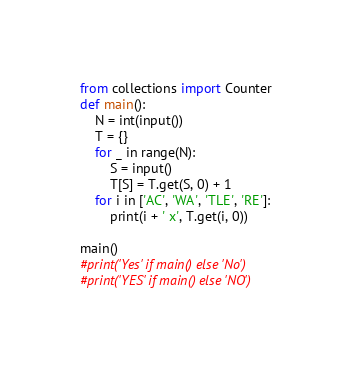Convert code to text. <code><loc_0><loc_0><loc_500><loc_500><_Python_>from collections import Counter
def main():
    N = int(input())
    T = {}
    for _ in range(N):
        S = input()
        T[S] = T.get(S, 0) + 1
    for i in ['AC', 'WA', 'TLE', 'RE']:
        print(i + ' x', T.get(i, 0))

main()
#print('Yes' if main() else 'No')
#print('YES' if main() else 'NO')
</code> 